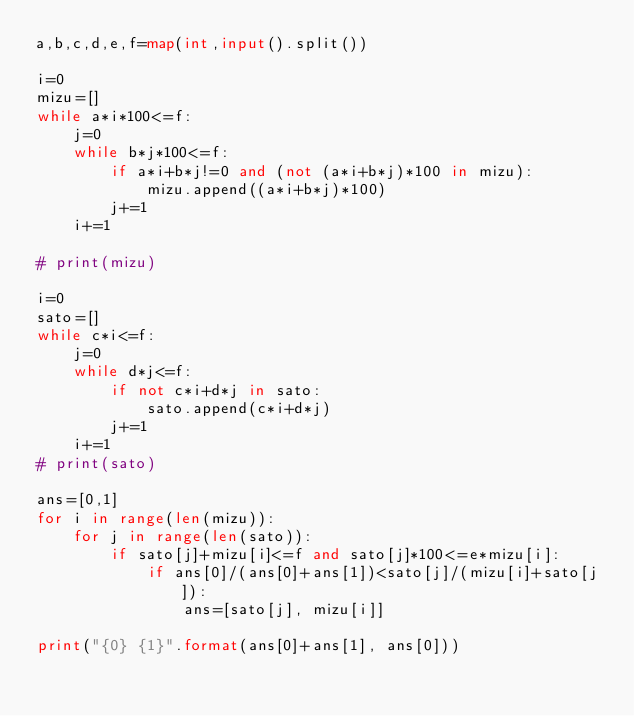<code> <loc_0><loc_0><loc_500><loc_500><_Python_>a,b,c,d,e,f=map(int,input().split())

i=0
mizu=[]
while a*i*100<=f:
    j=0
    while b*j*100<=f:
        if a*i+b*j!=0 and (not (a*i+b*j)*100 in mizu):
            mizu.append((a*i+b*j)*100)
        j+=1
    i+=1

# print(mizu)

i=0
sato=[]
while c*i<=f:
    j=0
    while d*j<=f:
        if not c*i+d*j in sato:
            sato.append(c*i+d*j)
        j+=1
    i+=1
# print(sato)

ans=[0,1]
for i in range(len(mizu)):
    for j in range(len(sato)):
        if sato[j]+mizu[i]<=f and sato[j]*100<=e*mizu[i]:
            if ans[0]/(ans[0]+ans[1])<sato[j]/(mizu[i]+sato[j]):
                ans=[sato[j], mizu[i]]

print("{0} {1}".format(ans[0]+ans[1], ans[0]))</code> 